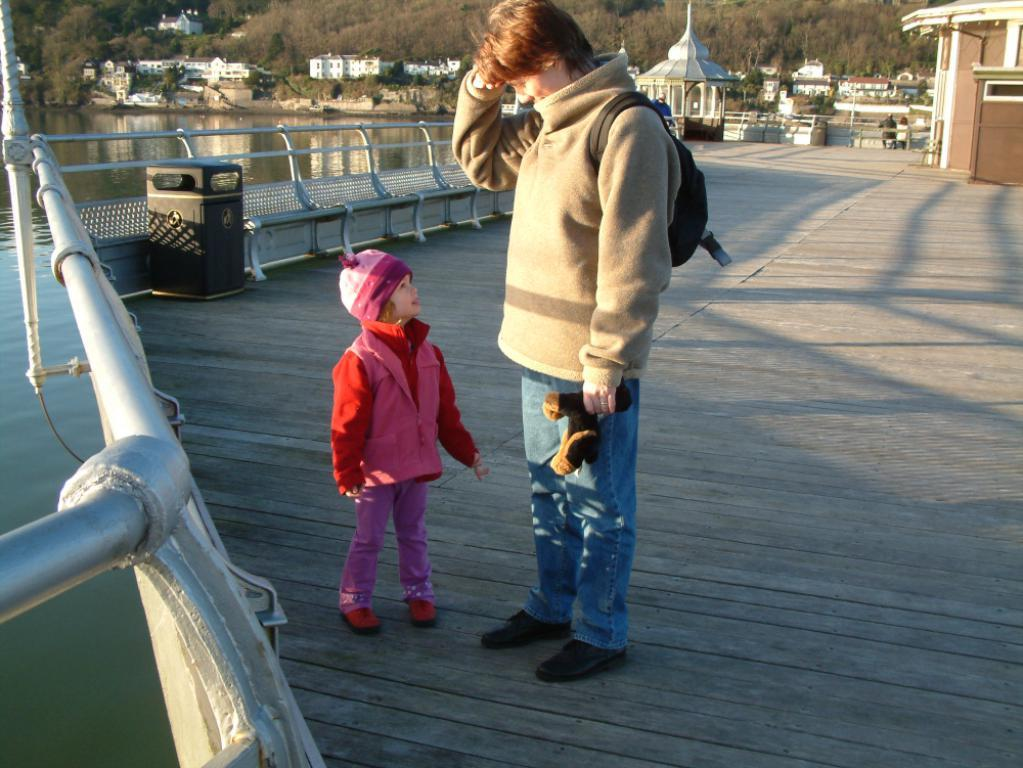What is the main subject in the middle of the image? There is a kid and a woman standing in the middle of the image. What can be seen in the background of the image? There are iron grills, a bin, buildings, trees, and water visible in the background of the image. What type of pies is the creator offering in the image? There is no mention of pies or a creator in the image. 